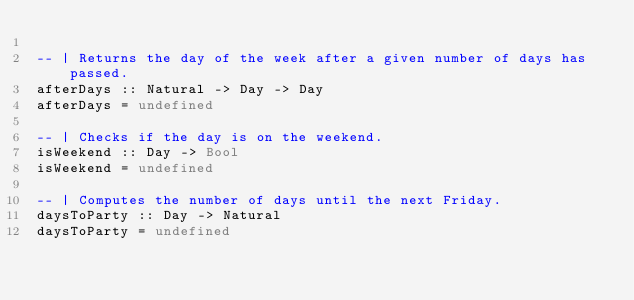Convert code to text. <code><loc_0><loc_0><loc_500><loc_500><_Haskell_>
-- | Returns the day of the week after a given number of days has passed.
afterDays :: Natural -> Day -> Day
afterDays = undefined

-- | Checks if the day is on the weekend.
isWeekend :: Day -> Bool
isWeekend = undefined

-- | Computes the number of days until the next Friday.
daysToParty :: Day -> Natural
daysToParty = undefined
</code> 